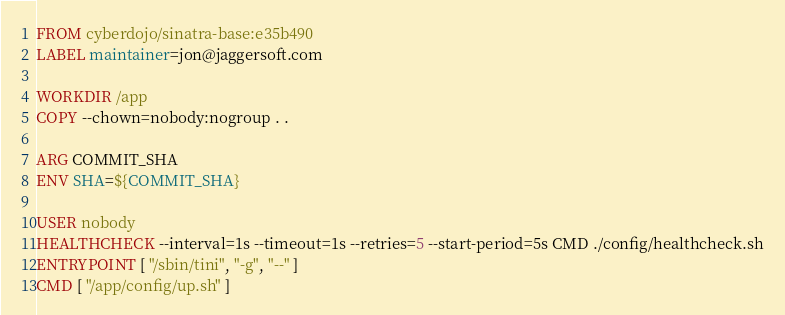<code> <loc_0><loc_0><loc_500><loc_500><_Dockerfile_>FROM cyberdojo/sinatra-base:e35b490
LABEL maintainer=jon@jaggersoft.com

WORKDIR /app
COPY --chown=nobody:nogroup . .

ARG COMMIT_SHA
ENV SHA=${COMMIT_SHA}

USER nobody
HEALTHCHECK --interval=1s --timeout=1s --retries=5 --start-period=5s CMD ./config/healthcheck.sh
ENTRYPOINT [ "/sbin/tini", "-g", "--" ]
CMD [ "/app/config/up.sh" ]
</code> 